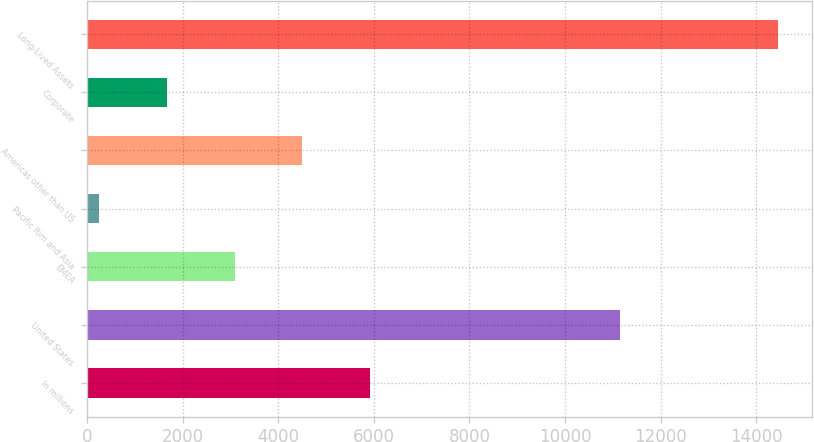Convert chart to OTSL. <chart><loc_0><loc_0><loc_500><loc_500><bar_chart><fcel>In millions<fcel>United States<fcel>EMEA<fcel>Pacific Rim and Asia<fcel>Americas other than US<fcel>Corporate<fcel>Long-Lived Assets<nl><fcel>5926<fcel>11158<fcel>3086<fcel>246<fcel>4506<fcel>1666<fcel>14446<nl></chart> 